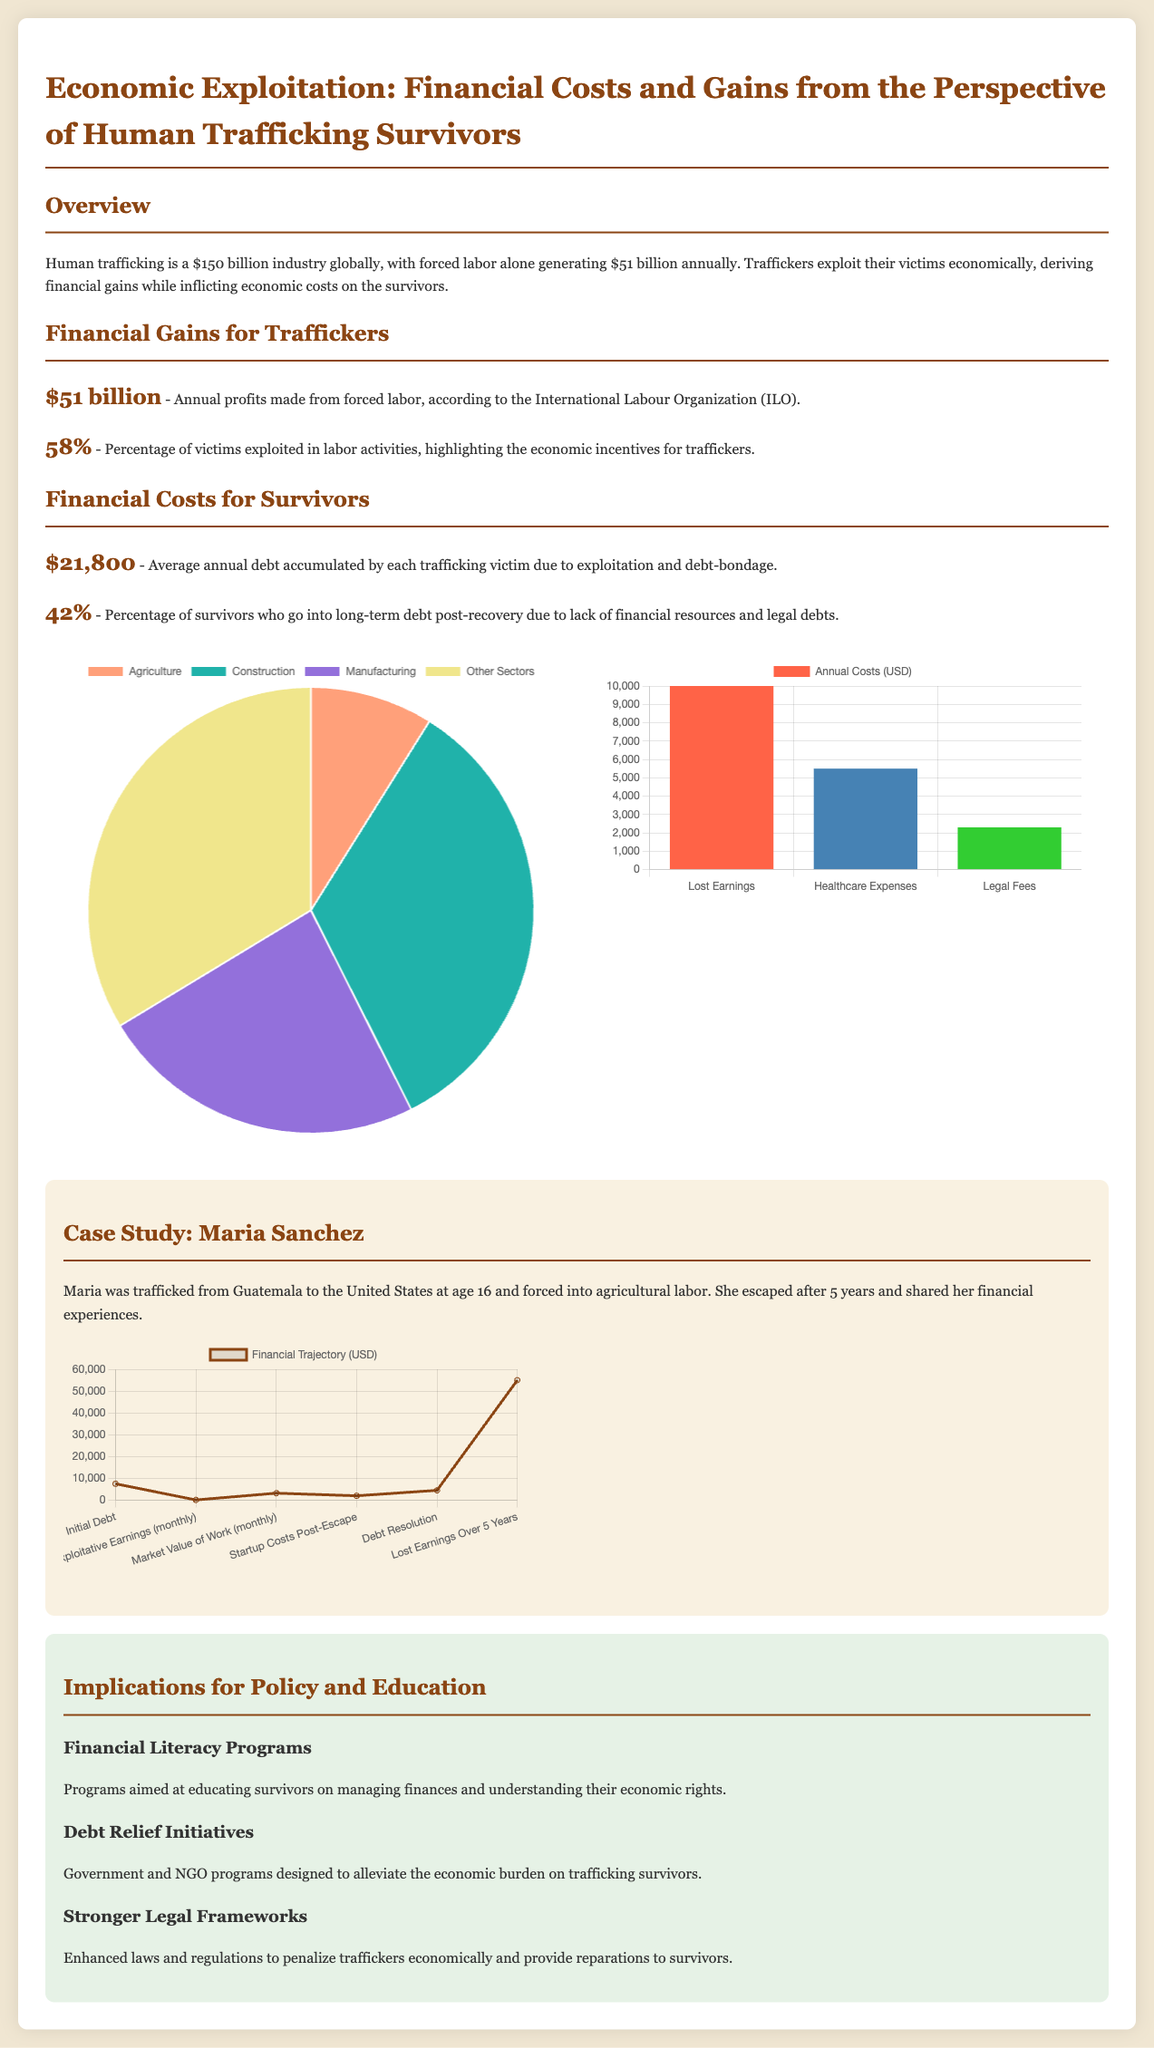What is the annual profit from forced labor according to the ILO? The document states that annual profits from forced labor total $51 billion.
Answer: $51 billion What percentage of victims are exploited in labor activities? The document indicates that 58% of victims are exploited in labor activities.
Answer: 58% What is the average annual debt accumulated by each trafficking victim? The average annual debt accumulated by each victim is stated as $21,800 in the document.
Answer: $21,800 What percentage of survivors go into long-term debt post-recovery? According to the document, 42% of survivors go into long-term debt after recovery.
Answer: 42% What sector generated the highest profits from forced labor? The document shows that the construction sector generates the highest profits at 34 billion dollars.
Answer: Construction What are the annual healthcare expenses for survivors? The document mentions that annual healthcare expenses for survivors are $5,500.
Answer: $5,500 What is the total lost earnings reported for a survivor over five years as described in Maria's financial trajectory? The document states that lost earnings over five years equal $55,000.
Answer: $55,000 What is one recommendation for improving survivor outcomes according to the implications section? The document recommends financial literacy programs as a way to improve outcomes for survivors.
Answer: Financial literacy programs What type of chart is used to represent global profits from forced labor? The document uses a pie chart to represent global profits from forced labor.
Answer: Pie chart 